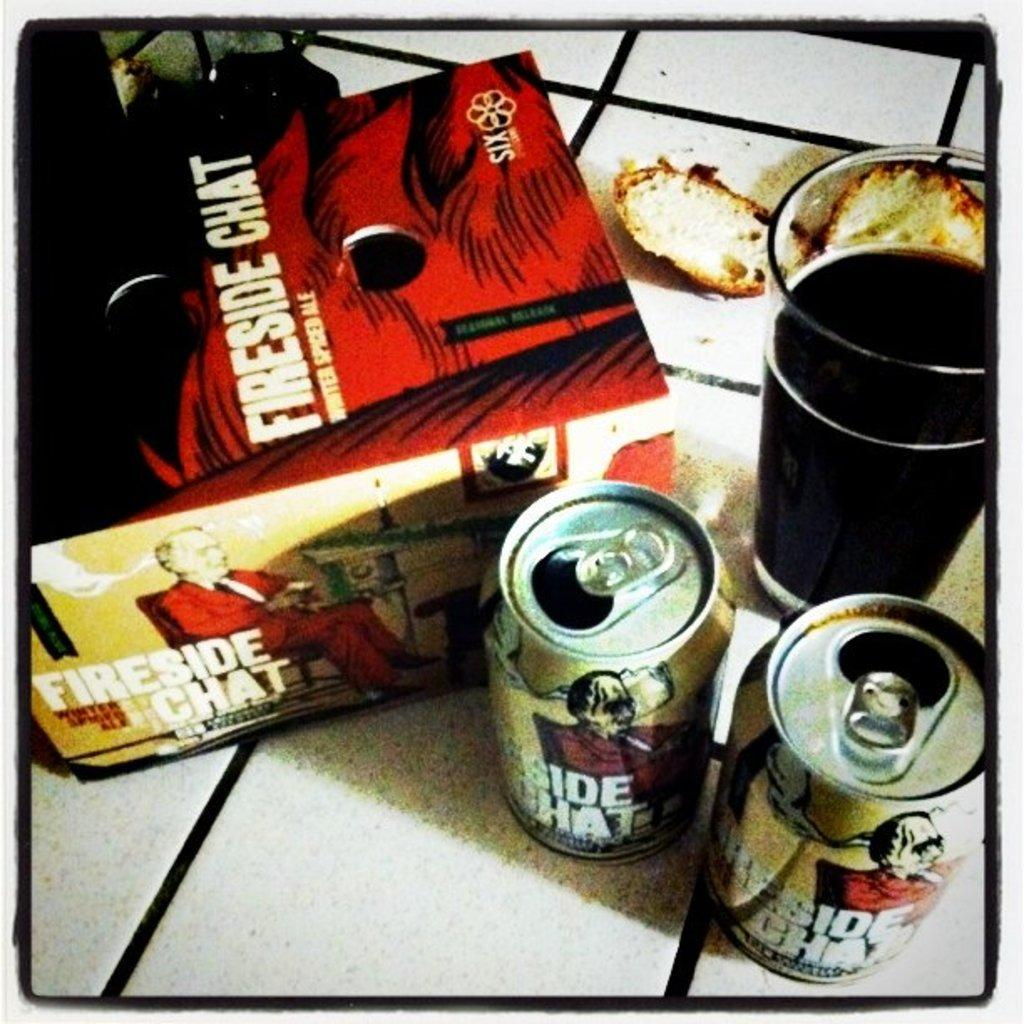<image>
Render a clear and concise summary of the photo. a beer box that says Fireside Chat on it 